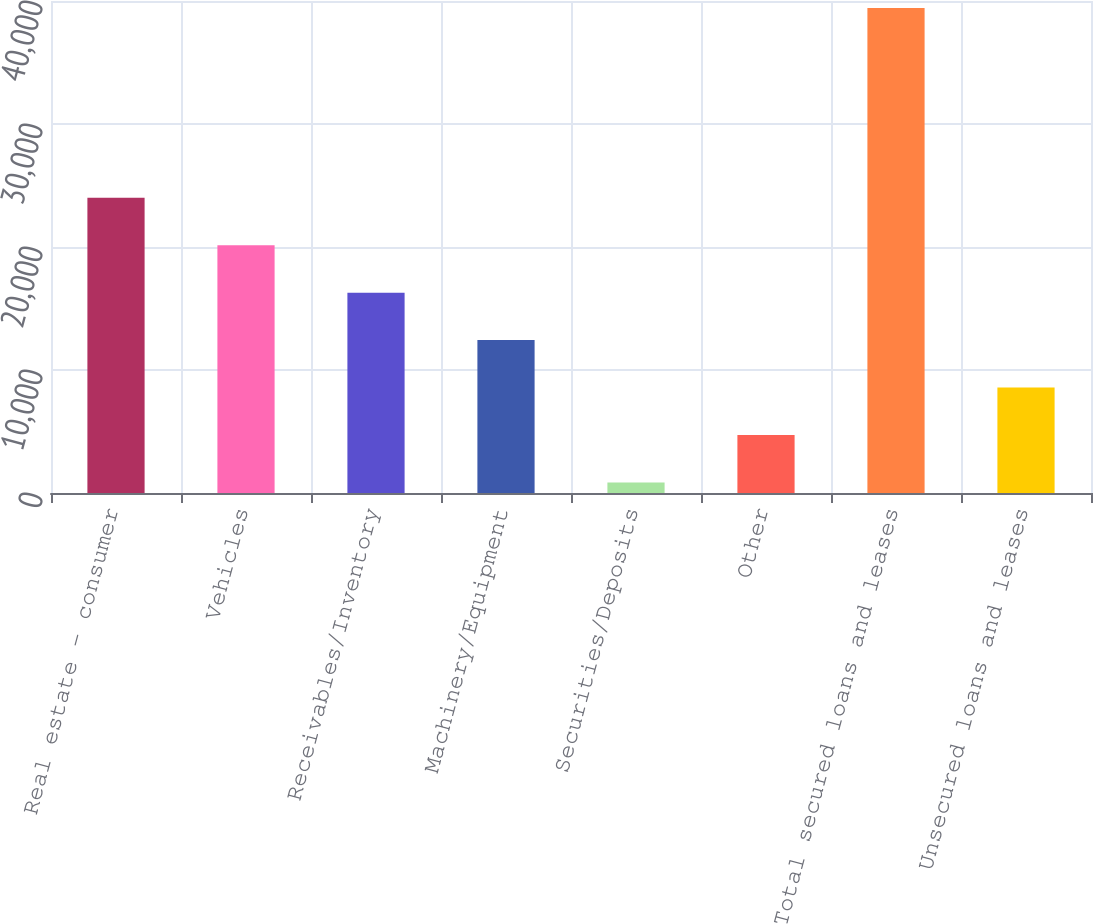Convert chart to OTSL. <chart><loc_0><loc_0><loc_500><loc_500><bar_chart><fcel>Real estate - consumer<fcel>Vehicles<fcel>Receivables/Inventory<fcel>Machinery/Equipment<fcel>Securities/Deposits<fcel>Other<fcel>Total secured loans and leases<fcel>Unsecured loans and leases<nl><fcel>24000.4<fcel>20144<fcel>16287.6<fcel>12431.2<fcel>862<fcel>4718.4<fcel>39426<fcel>8574.8<nl></chart> 